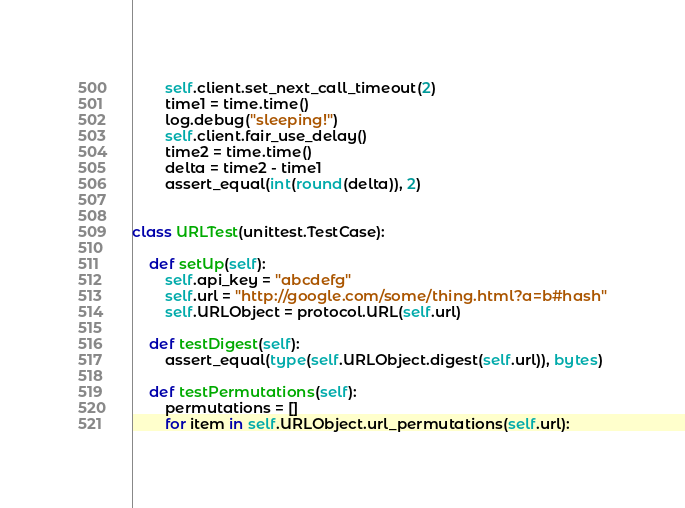<code> <loc_0><loc_0><loc_500><loc_500><_Python_>        self.client.set_next_call_timeout(2)
        time1 = time.time()
        log.debug("sleeping!")
        self.client.fair_use_delay()
        time2 = time.time()
        delta = time2 - time1
        assert_equal(int(round(delta)), 2)


class URLTest(unittest.TestCase):

    def setUp(self):
        self.api_key = "abcdefg"
        self.url = "http://google.com/some/thing.html?a=b#hash"
        self.URLObject = protocol.URL(self.url)

    def testDigest(self):
        assert_equal(type(self.URLObject.digest(self.url)), bytes)

    def testPermutations(self):
        permutations = []
        for item in self.URLObject.url_permutations(self.url):</code> 